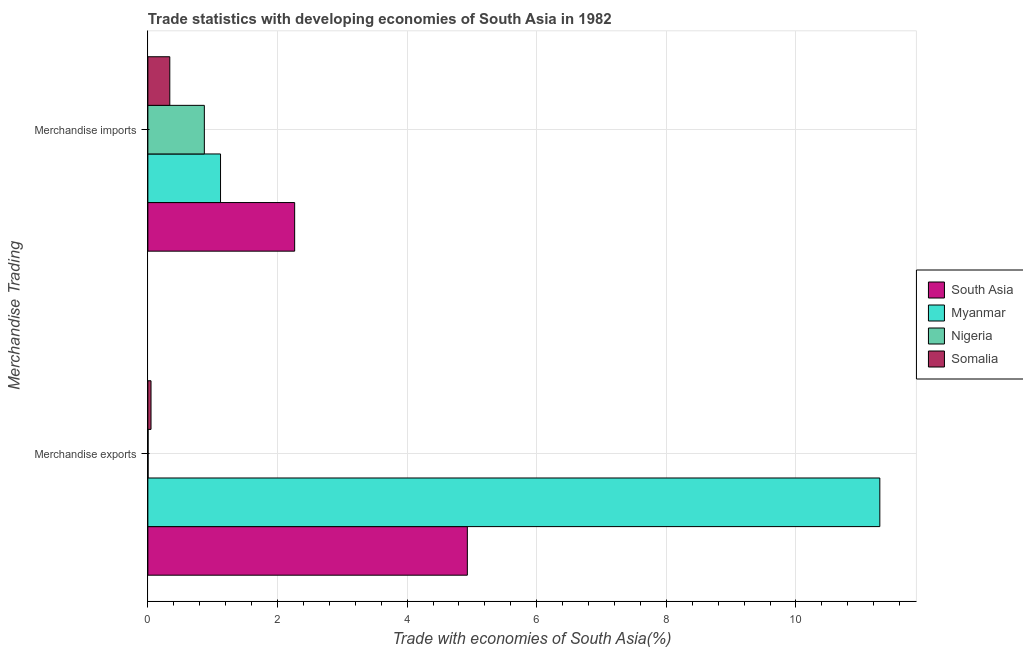How many different coloured bars are there?
Offer a very short reply. 4. What is the label of the 1st group of bars from the top?
Ensure brevity in your answer.  Merchandise imports. What is the merchandise exports in Myanmar?
Ensure brevity in your answer.  11.29. Across all countries, what is the maximum merchandise exports?
Give a very brief answer. 11.29. Across all countries, what is the minimum merchandise imports?
Offer a terse response. 0.34. In which country was the merchandise exports maximum?
Your answer should be very brief. Myanmar. In which country was the merchandise imports minimum?
Provide a succinct answer. Somalia. What is the total merchandise exports in the graph?
Make the answer very short. 16.28. What is the difference between the merchandise exports in Myanmar and that in Nigeria?
Make the answer very short. 11.29. What is the difference between the merchandise exports in Myanmar and the merchandise imports in Somalia?
Provide a succinct answer. 10.96. What is the average merchandise imports per country?
Your response must be concise. 1.15. What is the difference between the merchandise exports and merchandise imports in Myanmar?
Provide a short and direct response. 10.17. In how many countries, is the merchandise exports greater than 0.8 %?
Provide a succinct answer. 2. What is the ratio of the merchandise imports in Myanmar to that in Nigeria?
Give a very brief answer. 1.29. Is the merchandise imports in Myanmar less than that in Somalia?
Give a very brief answer. No. What does the 4th bar from the top in Merchandise exports represents?
Provide a succinct answer. South Asia. What does the 2nd bar from the bottom in Merchandise imports represents?
Provide a succinct answer. Myanmar. Are the values on the major ticks of X-axis written in scientific E-notation?
Give a very brief answer. No. Does the graph contain any zero values?
Give a very brief answer. No. Does the graph contain grids?
Give a very brief answer. Yes. Where does the legend appear in the graph?
Make the answer very short. Center right. What is the title of the graph?
Offer a very short reply. Trade statistics with developing economies of South Asia in 1982. Does "Congo (Republic)" appear as one of the legend labels in the graph?
Give a very brief answer. No. What is the label or title of the X-axis?
Make the answer very short. Trade with economies of South Asia(%). What is the label or title of the Y-axis?
Make the answer very short. Merchandise Trading. What is the Trade with economies of South Asia(%) of South Asia in Merchandise exports?
Your answer should be very brief. 4.93. What is the Trade with economies of South Asia(%) in Myanmar in Merchandise exports?
Make the answer very short. 11.29. What is the Trade with economies of South Asia(%) of Nigeria in Merchandise exports?
Offer a very short reply. 0. What is the Trade with economies of South Asia(%) of Somalia in Merchandise exports?
Offer a very short reply. 0.05. What is the Trade with economies of South Asia(%) of South Asia in Merchandise imports?
Provide a short and direct response. 2.26. What is the Trade with economies of South Asia(%) of Myanmar in Merchandise imports?
Give a very brief answer. 1.12. What is the Trade with economies of South Asia(%) in Nigeria in Merchandise imports?
Keep it short and to the point. 0.87. What is the Trade with economies of South Asia(%) in Somalia in Merchandise imports?
Your answer should be compact. 0.34. Across all Merchandise Trading, what is the maximum Trade with economies of South Asia(%) of South Asia?
Give a very brief answer. 4.93. Across all Merchandise Trading, what is the maximum Trade with economies of South Asia(%) in Myanmar?
Your answer should be very brief. 11.29. Across all Merchandise Trading, what is the maximum Trade with economies of South Asia(%) in Nigeria?
Provide a short and direct response. 0.87. Across all Merchandise Trading, what is the maximum Trade with economies of South Asia(%) of Somalia?
Give a very brief answer. 0.34. Across all Merchandise Trading, what is the minimum Trade with economies of South Asia(%) of South Asia?
Ensure brevity in your answer.  2.26. Across all Merchandise Trading, what is the minimum Trade with economies of South Asia(%) in Myanmar?
Keep it short and to the point. 1.12. Across all Merchandise Trading, what is the minimum Trade with economies of South Asia(%) in Nigeria?
Your answer should be compact. 0. Across all Merchandise Trading, what is the minimum Trade with economies of South Asia(%) in Somalia?
Make the answer very short. 0.05. What is the total Trade with economies of South Asia(%) in South Asia in the graph?
Your answer should be compact. 7.19. What is the total Trade with economies of South Asia(%) in Myanmar in the graph?
Your answer should be compact. 12.41. What is the total Trade with economies of South Asia(%) of Nigeria in the graph?
Your answer should be compact. 0.87. What is the total Trade with economies of South Asia(%) of Somalia in the graph?
Provide a short and direct response. 0.39. What is the difference between the Trade with economies of South Asia(%) of South Asia in Merchandise exports and that in Merchandise imports?
Provide a succinct answer. 2.66. What is the difference between the Trade with economies of South Asia(%) in Myanmar in Merchandise exports and that in Merchandise imports?
Keep it short and to the point. 10.17. What is the difference between the Trade with economies of South Asia(%) of Nigeria in Merchandise exports and that in Merchandise imports?
Offer a terse response. -0.87. What is the difference between the Trade with economies of South Asia(%) in Somalia in Merchandise exports and that in Merchandise imports?
Make the answer very short. -0.29. What is the difference between the Trade with economies of South Asia(%) of South Asia in Merchandise exports and the Trade with economies of South Asia(%) of Myanmar in Merchandise imports?
Your answer should be compact. 3.81. What is the difference between the Trade with economies of South Asia(%) of South Asia in Merchandise exports and the Trade with economies of South Asia(%) of Nigeria in Merchandise imports?
Keep it short and to the point. 4.06. What is the difference between the Trade with economies of South Asia(%) of South Asia in Merchandise exports and the Trade with economies of South Asia(%) of Somalia in Merchandise imports?
Your answer should be compact. 4.59. What is the difference between the Trade with economies of South Asia(%) in Myanmar in Merchandise exports and the Trade with economies of South Asia(%) in Nigeria in Merchandise imports?
Provide a short and direct response. 10.42. What is the difference between the Trade with economies of South Asia(%) in Myanmar in Merchandise exports and the Trade with economies of South Asia(%) in Somalia in Merchandise imports?
Make the answer very short. 10.96. What is the difference between the Trade with economies of South Asia(%) in Nigeria in Merchandise exports and the Trade with economies of South Asia(%) in Somalia in Merchandise imports?
Keep it short and to the point. -0.33. What is the average Trade with economies of South Asia(%) in South Asia per Merchandise Trading?
Keep it short and to the point. 3.6. What is the average Trade with economies of South Asia(%) in Myanmar per Merchandise Trading?
Make the answer very short. 6.21. What is the average Trade with economies of South Asia(%) in Nigeria per Merchandise Trading?
Offer a terse response. 0.44. What is the average Trade with economies of South Asia(%) in Somalia per Merchandise Trading?
Provide a short and direct response. 0.19. What is the difference between the Trade with economies of South Asia(%) of South Asia and Trade with economies of South Asia(%) of Myanmar in Merchandise exports?
Ensure brevity in your answer.  -6.36. What is the difference between the Trade with economies of South Asia(%) in South Asia and Trade with economies of South Asia(%) in Nigeria in Merchandise exports?
Your answer should be very brief. 4.93. What is the difference between the Trade with economies of South Asia(%) in South Asia and Trade with economies of South Asia(%) in Somalia in Merchandise exports?
Your response must be concise. 4.88. What is the difference between the Trade with economies of South Asia(%) in Myanmar and Trade with economies of South Asia(%) in Nigeria in Merchandise exports?
Provide a succinct answer. 11.29. What is the difference between the Trade with economies of South Asia(%) in Myanmar and Trade with economies of South Asia(%) in Somalia in Merchandise exports?
Offer a very short reply. 11.25. What is the difference between the Trade with economies of South Asia(%) of Nigeria and Trade with economies of South Asia(%) of Somalia in Merchandise exports?
Give a very brief answer. -0.05. What is the difference between the Trade with economies of South Asia(%) in South Asia and Trade with economies of South Asia(%) in Myanmar in Merchandise imports?
Offer a very short reply. 1.14. What is the difference between the Trade with economies of South Asia(%) in South Asia and Trade with economies of South Asia(%) in Nigeria in Merchandise imports?
Your answer should be compact. 1.39. What is the difference between the Trade with economies of South Asia(%) in South Asia and Trade with economies of South Asia(%) in Somalia in Merchandise imports?
Provide a short and direct response. 1.93. What is the difference between the Trade with economies of South Asia(%) of Myanmar and Trade with economies of South Asia(%) of Nigeria in Merchandise imports?
Offer a very short reply. 0.25. What is the difference between the Trade with economies of South Asia(%) in Myanmar and Trade with economies of South Asia(%) in Somalia in Merchandise imports?
Your answer should be compact. 0.78. What is the difference between the Trade with economies of South Asia(%) in Nigeria and Trade with economies of South Asia(%) in Somalia in Merchandise imports?
Provide a succinct answer. 0.53. What is the ratio of the Trade with economies of South Asia(%) of South Asia in Merchandise exports to that in Merchandise imports?
Ensure brevity in your answer.  2.18. What is the ratio of the Trade with economies of South Asia(%) in Myanmar in Merchandise exports to that in Merchandise imports?
Offer a very short reply. 10.07. What is the ratio of the Trade with economies of South Asia(%) in Nigeria in Merchandise exports to that in Merchandise imports?
Offer a terse response. 0. What is the ratio of the Trade with economies of South Asia(%) of Somalia in Merchandise exports to that in Merchandise imports?
Your answer should be compact. 0.14. What is the difference between the highest and the second highest Trade with economies of South Asia(%) in South Asia?
Provide a short and direct response. 2.66. What is the difference between the highest and the second highest Trade with economies of South Asia(%) of Myanmar?
Provide a succinct answer. 10.17. What is the difference between the highest and the second highest Trade with economies of South Asia(%) in Nigeria?
Give a very brief answer. 0.87. What is the difference between the highest and the second highest Trade with economies of South Asia(%) of Somalia?
Provide a short and direct response. 0.29. What is the difference between the highest and the lowest Trade with economies of South Asia(%) in South Asia?
Provide a short and direct response. 2.66. What is the difference between the highest and the lowest Trade with economies of South Asia(%) in Myanmar?
Keep it short and to the point. 10.17. What is the difference between the highest and the lowest Trade with economies of South Asia(%) in Nigeria?
Offer a very short reply. 0.87. What is the difference between the highest and the lowest Trade with economies of South Asia(%) in Somalia?
Keep it short and to the point. 0.29. 